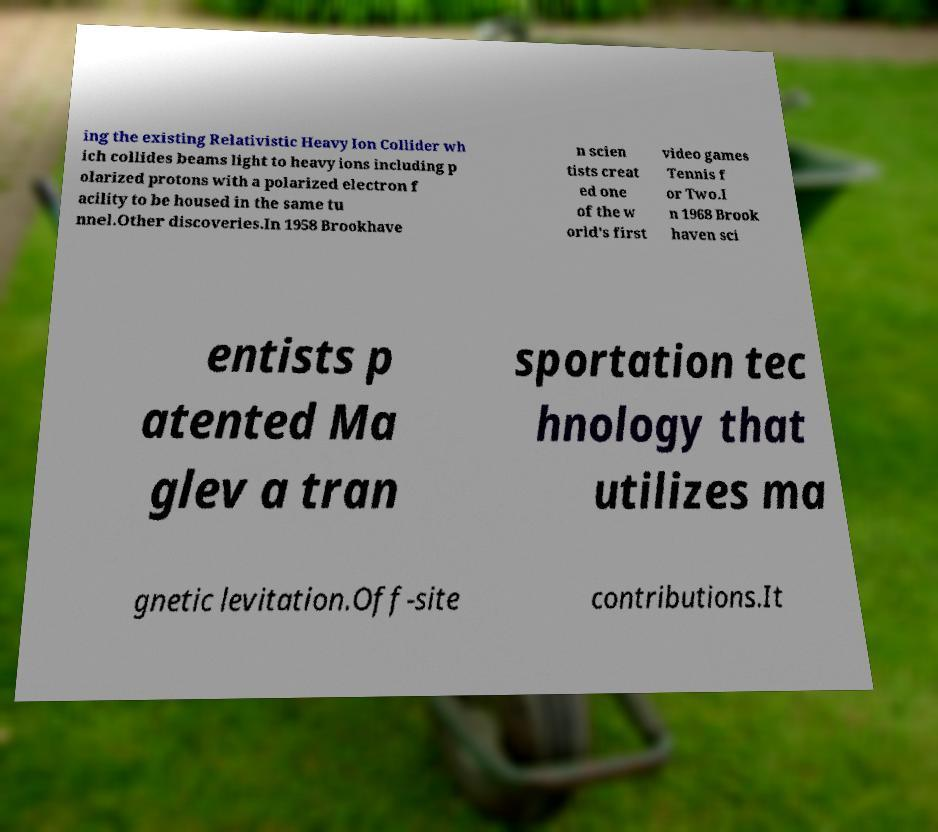Please read and relay the text visible in this image. What does it say? ing the existing Relativistic Heavy Ion Collider wh ich collides beams light to heavy ions including p olarized protons with a polarized electron f acility to be housed in the same tu nnel.Other discoveries.In 1958 Brookhave n scien tists creat ed one of the w orld's first video games Tennis f or Two.I n 1968 Brook haven sci entists p atented Ma glev a tran sportation tec hnology that utilizes ma gnetic levitation.Off-site contributions.It 